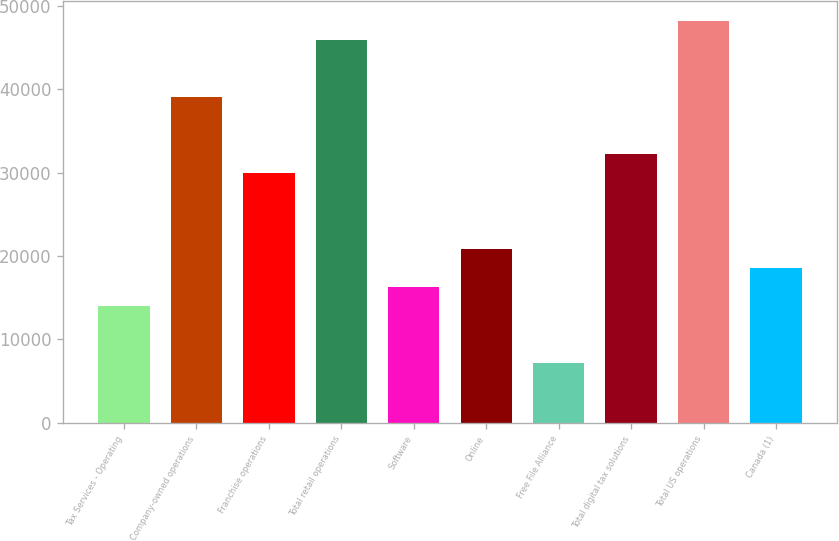Convert chart. <chart><loc_0><loc_0><loc_500><loc_500><bar_chart><fcel>Tax Services - Operating<fcel>Company-owned operations<fcel>Franchise operations<fcel>Total retail operations<fcel>Software<fcel>Online<fcel>Free File Alliance<fcel>Total digital tax solutions<fcel>Total US operations<fcel>Canada (1)<nl><fcel>14059<fcel>39089.5<fcel>29987.5<fcel>45916<fcel>16334.5<fcel>20885.5<fcel>7232.5<fcel>32263<fcel>48191.5<fcel>18610<nl></chart> 